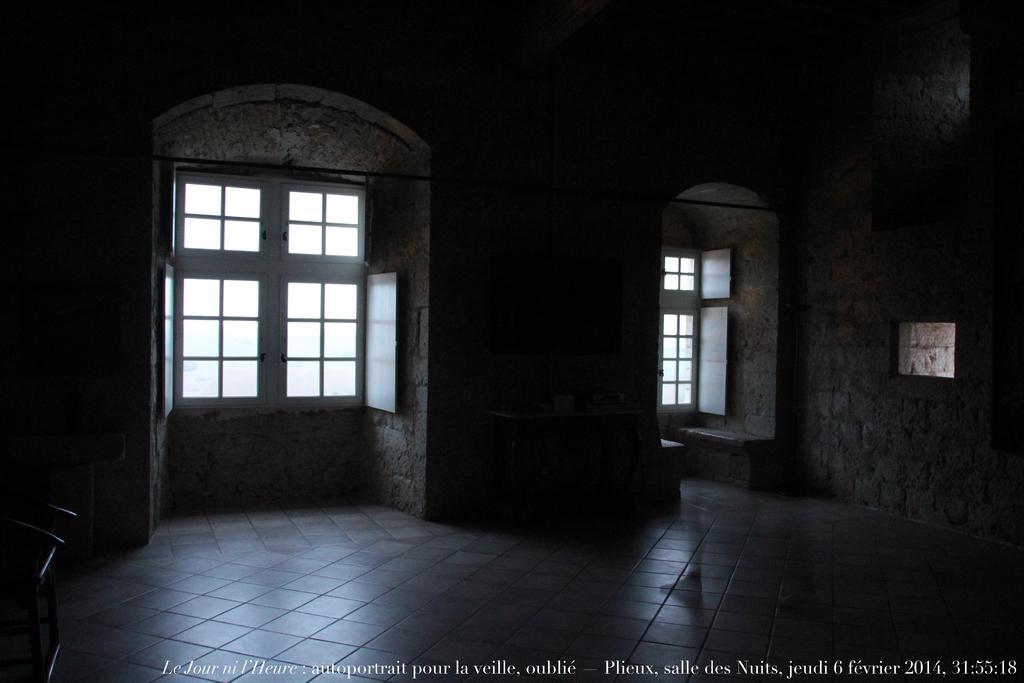Please provide a concise description of this image. In this picture we can see the wall, windows. On the left side of the picture we can see an object. At the bottom portion of the picture we can see the floor and some information. Person legs are visible in this picture. 